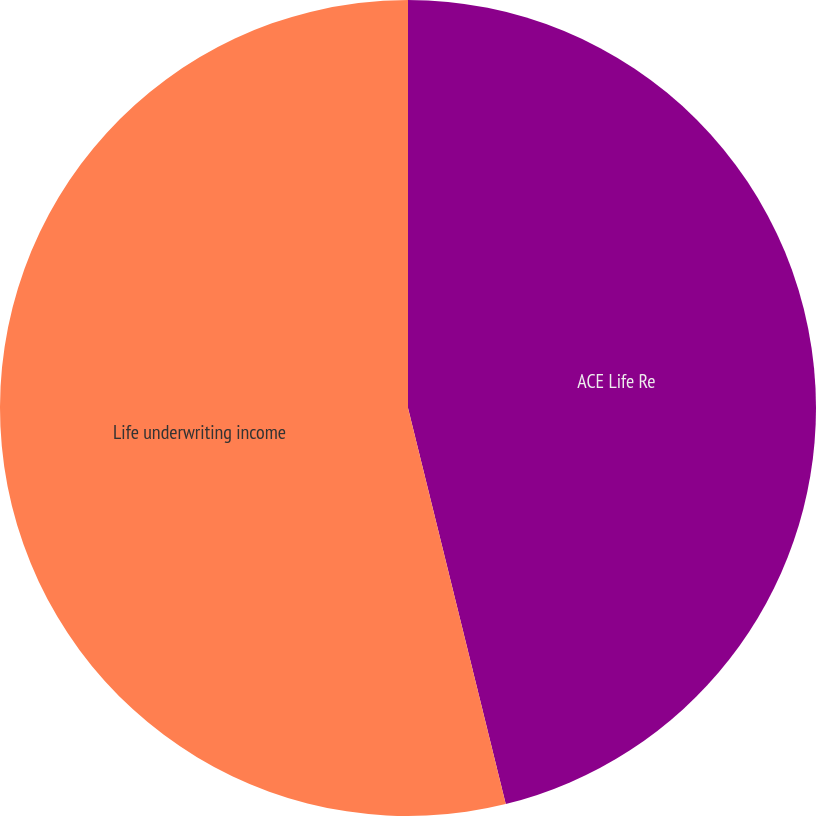<chart> <loc_0><loc_0><loc_500><loc_500><pie_chart><fcel>ACE Life Re<fcel>Life underwriting income<nl><fcel>46.15%<fcel>53.85%<nl></chart> 